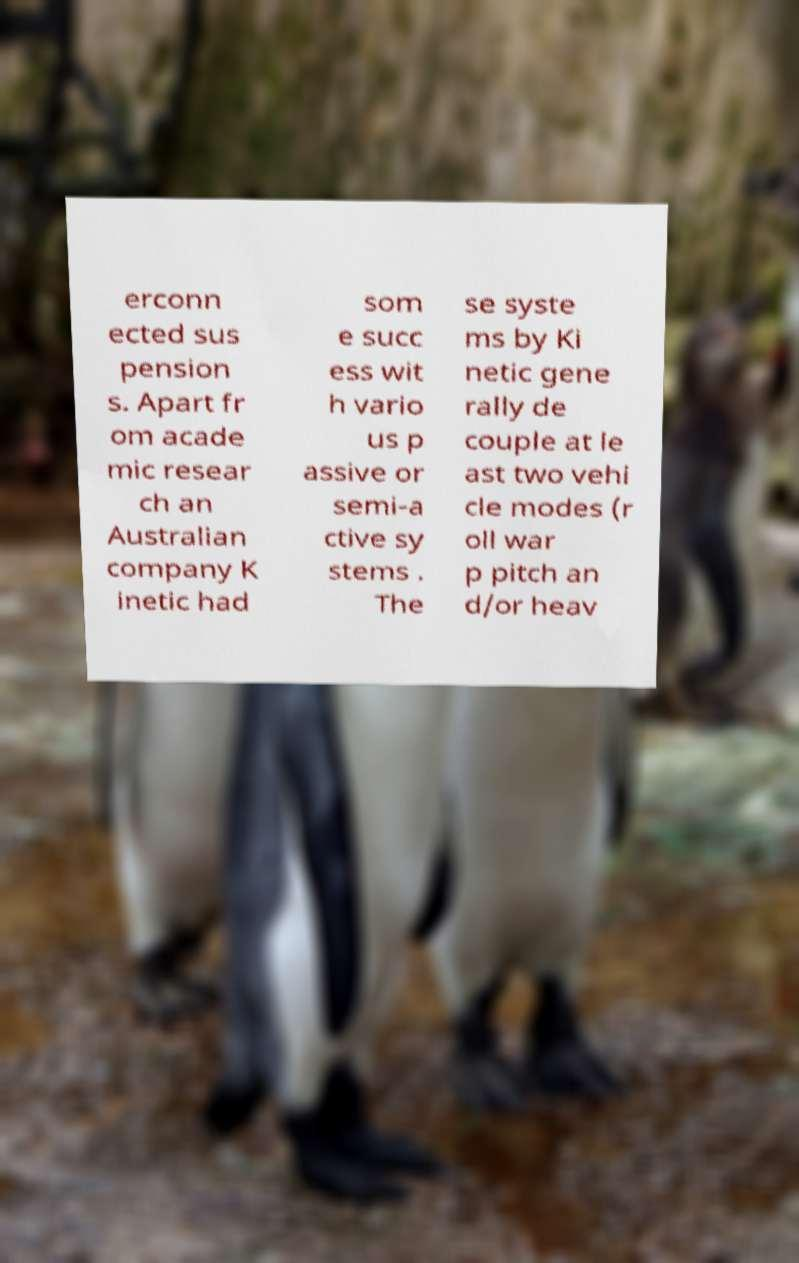Please read and relay the text visible in this image. What does it say? erconn ected sus pension s. Apart fr om acade mic resear ch an Australian company K inetic had som e succ ess wit h vario us p assive or semi-a ctive sy stems . The se syste ms by Ki netic gene rally de couple at le ast two vehi cle modes (r oll war p pitch an d/or heav 